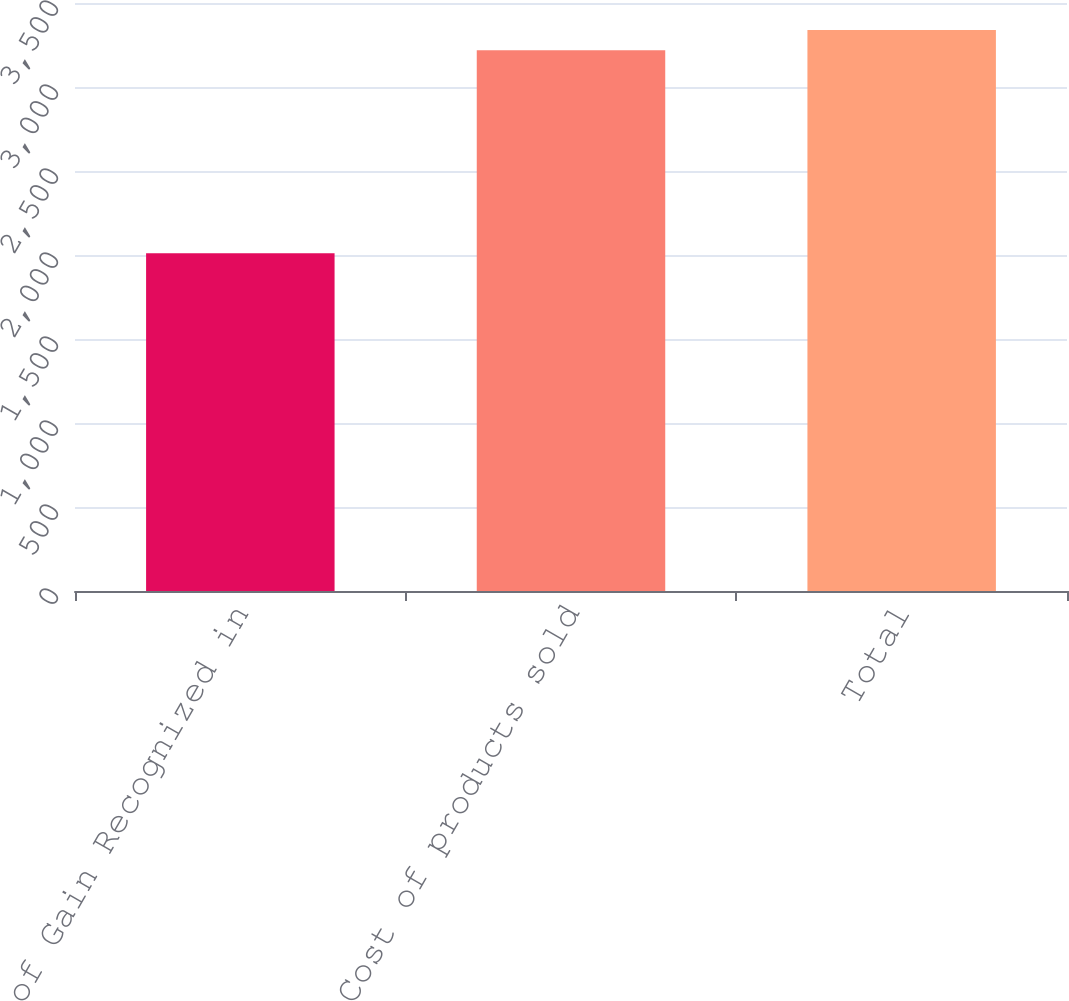Convert chart to OTSL. <chart><loc_0><loc_0><loc_500><loc_500><bar_chart><fcel>Location of Gain Recognized in<fcel>Cost of products sold<fcel>Total<nl><fcel>2011<fcel>3219<fcel>3339.8<nl></chart> 